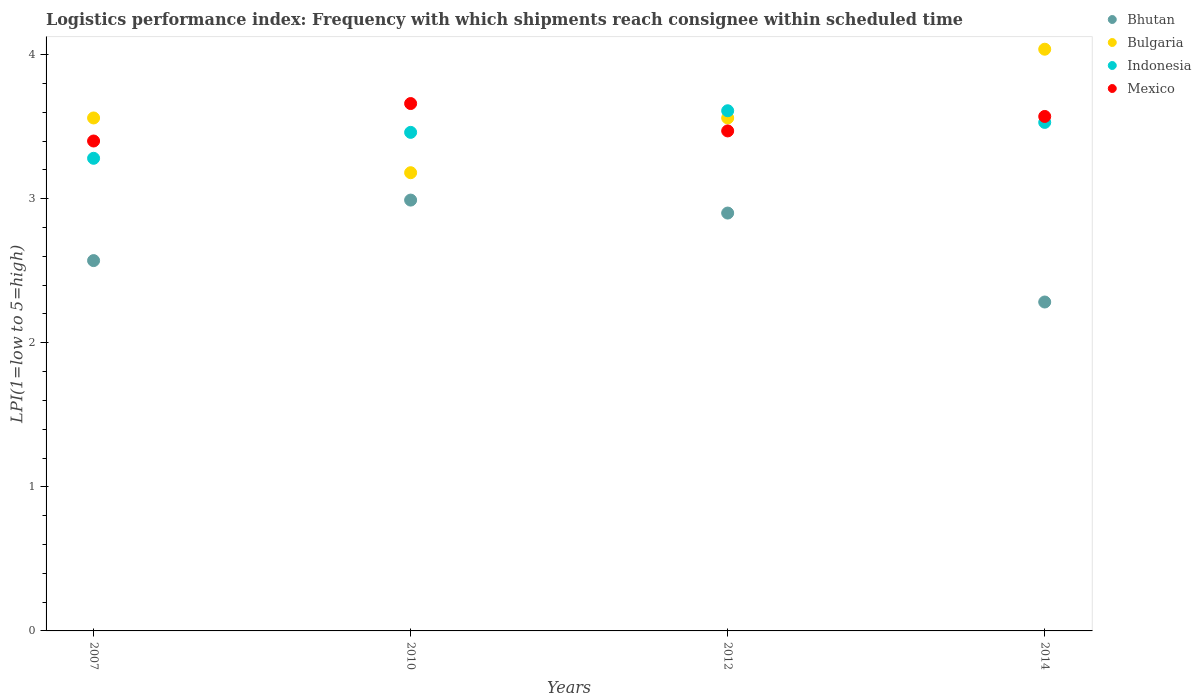Is the number of dotlines equal to the number of legend labels?
Your answer should be compact. Yes. What is the logistics performance index in Mexico in 2010?
Your response must be concise. 3.66. Across all years, what is the maximum logistics performance index in Bulgaria?
Your answer should be compact. 4.04. Across all years, what is the minimum logistics performance index in Bulgaria?
Your answer should be very brief. 3.18. In which year was the logistics performance index in Bulgaria maximum?
Your answer should be compact. 2014. In which year was the logistics performance index in Mexico minimum?
Offer a very short reply. 2007. What is the total logistics performance index in Bulgaria in the graph?
Ensure brevity in your answer.  14.34. What is the difference between the logistics performance index in Indonesia in 2007 and that in 2014?
Your response must be concise. -0.25. What is the difference between the logistics performance index in Indonesia in 2014 and the logistics performance index in Bhutan in 2010?
Offer a very short reply. 0.54. What is the average logistics performance index in Bhutan per year?
Keep it short and to the point. 2.69. In the year 2014, what is the difference between the logistics performance index in Mexico and logistics performance index in Bulgaria?
Ensure brevity in your answer.  -0.47. In how many years, is the logistics performance index in Bulgaria greater than 3.4?
Your answer should be compact. 3. What is the ratio of the logistics performance index in Mexico in 2010 to that in 2014?
Offer a very short reply. 1.03. Is the logistics performance index in Indonesia in 2012 less than that in 2014?
Keep it short and to the point. No. What is the difference between the highest and the second highest logistics performance index in Bulgaria?
Give a very brief answer. 0.48. What is the difference between the highest and the lowest logistics performance index in Mexico?
Your response must be concise. 0.26. In how many years, is the logistics performance index in Mexico greater than the average logistics performance index in Mexico taken over all years?
Your response must be concise. 2. Is it the case that in every year, the sum of the logistics performance index in Indonesia and logistics performance index in Bulgaria  is greater than the logistics performance index in Bhutan?
Make the answer very short. Yes. Does the logistics performance index in Bhutan monotonically increase over the years?
Keep it short and to the point. No. How many dotlines are there?
Your response must be concise. 4. What is the difference between two consecutive major ticks on the Y-axis?
Your answer should be compact. 1. Are the values on the major ticks of Y-axis written in scientific E-notation?
Provide a succinct answer. No. Where does the legend appear in the graph?
Your answer should be very brief. Top right. How many legend labels are there?
Keep it short and to the point. 4. What is the title of the graph?
Offer a terse response. Logistics performance index: Frequency with which shipments reach consignee within scheduled time. What is the label or title of the X-axis?
Provide a short and direct response. Years. What is the label or title of the Y-axis?
Provide a short and direct response. LPI(1=low to 5=high). What is the LPI(1=low to 5=high) in Bhutan in 2007?
Keep it short and to the point. 2.57. What is the LPI(1=low to 5=high) of Bulgaria in 2007?
Provide a succinct answer. 3.56. What is the LPI(1=low to 5=high) in Indonesia in 2007?
Your answer should be very brief. 3.28. What is the LPI(1=low to 5=high) in Mexico in 2007?
Your response must be concise. 3.4. What is the LPI(1=low to 5=high) in Bhutan in 2010?
Offer a terse response. 2.99. What is the LPI(1=low to 5=high) in Bulgaria in 2010?
Provide a succinct answer. 3.18. What is the LPI(1=low to 5=high) in Indonesia in 2010?
Provide a succinct answer. 3.46. What is the LPI(1=low to 5=high) in Mexico in 2010?
Your answer should be very brief. 3.66. What is the LPI(1=low to 5=high) in Bulgaria in 2012?
Provide a succinct answer. 3.56. What is the LPI(1=low to 5=high) in Indonesia in 2012?
Make the answer very short. 3.61. What is the LPI(1=low to 5=high) of Mexico in 2012?
Make the answer very short. 3.47. What is the LPI(1=low to 5=high) in Bhutan in 2014?
Provide a short and direct response. 2.28. What is the LPI(1=low to 5=high) in Bulgaria in 2014?
Offer a very short reply. 4.04. What is the LPI(1=low to 5=high) of Indonesia in 2014?
Provide a succinct answer. 3.53. What is the LPI(1=low to 5=high) in Mexico in 2014?
Make the answer very short. 3.57. Across all years, what is the maximum LPI(1=low to 5=high) of Bhutan?
Make the answer very short. 2.99. Across all years, what is the maximum LPI(1=low to 5=high) of Bulgaria?
Provide a short and direct response. 4.04. Across all years, what is the maximum LPI(1=low to 5=high) of Indonesia?
Ensure brevity in your answer.  3.61. Across all years, what is the maximum LPI(1=low to 5=high) of Mexico?
Make the answer very short. 3.66. Across all years, what is the minimum LPI(1=low to 5=high) of Bhutan?
Make the answer very short. 2.28. Across all years, what is the minimum LPI(1=low to 5=high) of Bulgaria?
Make the answer very short. 3.18. Across all years, what is the minimum LPI(1=low to 5=high) of Indonesia?
Ensure brevity in your answer.  3.28. Across all years, what is the minimum LPI(1=low to 5=high) in Mexico?
Offer a very short reply. 3.4. What is the total LPI(1=low to 5=high) in Bhutan in the graph?
Give a very brief answer. 10.74. What is the total LPI(1=low to 5=high) in Bulgaria in the graph?
Offer a very short reply. 14.34. What is the total LPI(1=low to 5=high) of Indonesia in the graph?
Provide a short and direct response. 13.88. What is the total LPI(1=low to 5=high) of Mexico in the graph?
Your answer should be very brief. 14.1. What is the difference between the LPI(1=low to 5=high) in Bhutan in 2007 and that in 2010?
Provide a succinct answer. -0.42. What is the difference between the LPI(1=low to 5=high) of Bulgaria in 2007 and that in 2010?
Your answer should be very brief. 0.38. What is the difference between the LPI(1=low to 5=high) in Indonesia in 2007 and that in 2010?
Make the answer very short. -0.18. What is the difference between the LPI(1=low to 5=high) in Mexico in 2007 and that in 2010?
Provide a succinct answer. -0.26. What is the difference between the LPI(1=low to 5=high) of Bhutan in 2007 and that in 2012?
Provide a succinct answer. -0.33. What is the difference between the LPI(1=low to 5=high) of Indonesia in 2007 and that in 2012?
Provide a short and direct response. -0.33. What is the difference between the LPI(1=low to 5=high) of Mexico in 2007 and that in 2012?
Provide a succinct answer. -0.07. What is the difference between the LPI(1=low to 5=high) in Bhutan in 2007 and that in 2014?
Your answer should be very brief. 0.29. What is the difference between the LPI(1=low to 5=high) of Bulgaria in 2007 and that in 2014?
Ensure brevity in your answer.  -0.48. What is the difference between the LPI(1=low to 5=high) of Indonesia in 2007 and that in 2014?
Make the answer very short. -0.25. What is the difference between the LPI(1=low to 5=high) of Mexico in 2007 and that in 2014?
Give a very brief answer. -0.17. What is the difference between the LPI(1=low to 5=high) of Bhutan in 2010 and that in 2012?
Provide a short and direct response. 0.09. What is the difference between the LPI(1=low to 5=high) of Bulgaria in 2010 and that in 2012?
Offer a very short reply. -0.38. What is the difference between the LPI(1=low to 5=high) of Indonesia in 2010 and that in 2012?
Your response must be concise. -0.15. What is the difference between the LPI(1=low to 5=high) in Mexico in 2010 and that in 2012?
Your answer should be compact. 0.19. What is the difference between the LPI(1=low to 5=high) of Bhutan in 2010 and that in 2014?
Offer a very short reply. 0.71. What is the difference between the LPI(1=low to 5=high) of Bulgaria in 2010 and that in 2014?
Ensure brevity in your answer.  -0.86. What is the difference between the LPI(1=low to 5=high) of Indonesia in 2010 and that in 2014?
Offer a terse response. -0.07. What is the difference between the LPI(1=low to 5=high) in Mexico in 2010 and that in 2014?
Make the answer very short. 0.09. What is the difference between the LPI(1=low to 5=high) in Bhutan in 2012 and that in 2014?
Provide a succinct answer. 0.62. What is the difference between the LPI(1=low to 5=high) in Bulgaria in 2012 and that in 2014?
Ensure brevity in your answer.  -0.48. What is the difference between the LPI(1=low to 5=high) of Indonesia in 2012 and that in 2014?
Your answer should be very brief. 0.08. What is the difference between the LPI(1=low to 5=high) of Mexico in 2012 and that in 2014?
Give a very brief answer. -0.1. What is the difference between the LPI(1=low to 5=high) of Bhutan in 2007 and the LPI(1=low to 5=high) of Bulgaria in 2010?
Your answer should be very brief. -0.61. What is the difference between the LPI(1=low to 5=high) in Bhutan in 2007 and the LPI(1=low to 5=high) in Indonesia in 2010?
Ensure brevity in your answer.  -0.89. What is the difference between the LPI(1=low to 5=high) in Bhutan in 2007 and the LPI(1=low to 5=high) in Mexico in 2010?
Offer a terse response. -1.09. What is the difference between the LPI(1=low to 5=high) in Bulgaria in 2007 and the LPI(1=low to 5=high) in Indonesia in 2010?
Provide a succinct answer. 0.1. What is the difference between the LPI(1=low to 5=high) of Bulgaria in 2007 and the LPI(1=low to 5=high) of Mexico in 2010?
Keep it short and to the point. -0.1. What is the difference between the LPI(1=low to 5=high) in Indonesia in 2007 and the LPI(1=low to 5=high) in Mexico in 2010?
Your answer should be compact. -0.38. What is the difference between the LPI(1=low to 5=high) in Bhutan in 2007 and the LPI(1=low to 5=high) in Bulgaria in 2012?
Your answer should be compact. -0.99. What is the difference between the LPI(1=low to 5=high) in Bhutan in 2007 and the LPI(1=low to 5=high) in Indonesia in 2012?
Make the answer very short. -1.04. What is the difference between the LPI(1=low to 5=high) of Bulgaria in 2007 and the LPI(1=low to 5=high) of Indonesia in 2012?
Keep it short and to the point. -0.05. What is the difference between the LPI(1=low to 5=high) in Bulgaria in 2007 and the LPI(1=low to 5=high) in Mexico in 2012?
Offer a very short reply. 0.09. What is the difference between the LPI(1=low to 5=high) in Indonesia in 2007 and the LPI(1=low to 5=high) in Mexico in 2012?
Offer a terse response. -0.19. What is the difference between the LPI(1=low to 5=high) in Bhutan in 2007 and the LPI(1=low to 5=high) in Bulgaria in 2014?
Keep it short and to the point. -1.47. What is the difference between the LPI(1=low to 5=high) in Bhutan in 2007 and the LPI(1=low to 5=high) in Indonesia in 2014?
Offer a terse response. -0.96. What is the difference between the LPI(1=low to 5=high) in Bhutan in 2007 and the LPI(1=low to 5=high) in Mexico in 2014?
Your answer should be very brief. -1. What is the difference between the LPI(1=low to 5=high) of Bulgaria in 2007 and the LPI(1=low to 5=high) of Indonesia in 2014?
Your answer should be very brief. 0.03. What is the difference between the LPI(1=low to 5=high) in Bulgaria in 2007 and the LPI(1=low to 5=high) in Mexico in 2014?
Keep it short and to the point. -0.01. What is the difference between the LPI(1=low to 5=high) in Indonesia in 2007 and the LPI(1=low to 5=high) in Mexico in 2014?
Ensure brevity in your answer.  -0.29. What is the difference between the LPI(1=low to 5=high) in Bhutan in 2010 and the LPI(1=low to 5=high) in Bulgaria in 2012?
Provide a short and direct response. -0.57. What is the difference between the LPI(1=low to 5=high) in Bhutan in 2010 and the LPI(1=low to 5=high) in Indonesia in 2012?
Make the answer very short. -0.62. What is the difference between the LPI(1=low to 5=high) in Bhutan in 2010 and the LPI(1=low to 5=high) in Mexico in 2012?
Offer a very short reply. -0.48. What is the difference between the LPI(1=low to 5=high) in Bulgaria in 2010 and the LPI(1=low to 5=high) in Indonesia in 2012?
Provide a short and direct response. -0.43. What is the difference between the LPI(1=low to 5=high) in Bulgaria in 2010 and the LPI(1=low to 5=high) in Mexico in 2012?
Your response must be concise. -0.29. What is the difference between the LPI(1=low to 5=high) in Indonesia in 2010 and the LPI(1=low to 5=high) in Mexico in 2012?
Offer a terse response. -0.01. What is the difference between the LPI(1=low to 5=high) in Bhutan in 2010 and the LPI(1=low to 5=high) in Bulgaria in 2014?
Keep it short and to the point. -1.05. What is the difference between the LPI(1=low to 5=high) of Bhutan in 2010 and the LPI(1=low to 5=high) of Indonesia in 2014?
Give a very brief answer. -0.54. What is the difference between the LPI(1=low to 5=high) of Bhutan in 2010 and the LPI(1=low to 5=high) of Mexico in 2014?
Provide a short and direct response. -0.58. What is the difference between the LPI(1=low to 5=high) in Bulgaria in 2010 and the LPI(1=low to 5=high) in Indonesia in 2014?
Provide a short and direct response. -0.35. What is the difference between the LPI(1=low to 5=high) of Bulgaria in 2010 and the LPI(1=low to 5=high) of Mexico in 2014?
Keep it short and to the point. -0.39. What is the difference between the LPI(1=low to 5=high) of Indonesia in 2010 and the LPI(1=low to 5=high) of Mexico in 2014?
Offer a very short reply. -0.11. What is the difference between the LPI(1=low to 5=high) in Bhutan in 2012 and the LPI(1=low to 5=high) in Bulgaria in 2014?
Make the answer very short. -1.14. What is the difference between the LPI(1=low to 5=high) in Bhutan in 2012 and the LPI(1=low to 5=high) in Indonesia in 2014?
Offer a very short reply. -0.63. What is the difference between the LPI(1=low to 5=high) in Bhutan in 2012 and the LPI(1=low to 5=high) in Mexico in 2014?
Provide a succinct answer. -0.67. What is the difference between the LPI(1=low to 5=high) of Bulgaria in 2012 and the LPI(1=low to 5=high) of Indonesia in 2014?
Provide a short and direct response. 0.03. What is the difference between the LPI(1=low to 5=high) in Bulgaria in 2012 and the LPI(1=low to 5=high) in Mexico in 2014?
Your answer should be very brief. -0.01. What is the difference between the LPI(1=low to 5=high) of Indonesia in 2012 and the LPI(1=low to 5=high) of Mexico in 2014?
Give a very brief answer. 0.04. What is the average LPI(1=low to 5=high) of Bhutan per year?
Keep it short and to the point. 2.69. What is the average LPI(1=low to 5=high) of Bulgaria per year?
Keep it short and to the point. 3.58. What is the average LPI(1=low to 5=high) of Indonesia per year?
Your answer should be very brief. 3.47. What is the average LPI(1=low to 5=high) in Mexico per year?
Your answer should be very brief. 3.53. In the year 2007, what is the difference between the LPI(1=low to 5=high) of Bhutan and LPI(1=low to 5=high) of Bulgaria?
Provide a short and direct response. -0.99. In the year 2007, what is the difference between the LPI(1=low to 5=high) of Bhutan and LPI(1=low to 5=high) of Indonesia?
Keep it short and to the point. -0.71. In the year 2007, what is the difference between the LPI(1=low to 5=high) in Bhutan and LPI(1=low to 5=high) in Mexico?
Provide a short and direct response. -0.83. In the year 2007, what is the difference between the LPI(1=low to 5=high) of Bulgaria and LPI(1=low to 5=high) of Indonesia?
Your response must be concise. 0.28. In the year 2007, what is the difference between the LPI(1=low to 5=high) in Bulgaria and LPI(1=low to 5=high) in Mexico?
Your response must be concise. 0.16. In the year 2007, what is the difference between the LPI(1=low to 5=high) of Indonesia and LPI(1=low to 5=high) of Mexico?
Your answer should be very brief. -0.12. In the year 2010, what is the difference between the LPI(1=low to 5=high) in Bhutan and LPI(1=low to 5=high) in Bulgaria?
Give a very brief answer. -0.19. In the year 2010, what is the difference between the LPI(1=low to 5=high) in Bhutan and LPI(1=low to 5=high) in Indonesia?
Your response must be concise. -0.47. In the year 2010, what is the difference between the LPI(1=low to 5=high) of Bhutan and LPI(1=low to 5=high) of Mexico?
Your answer should be very brief. -0.67. In the year 2010, what is the difference between the LPI(1=low to 5=high) in Bulgaria and LPI(1=low to 5=high) in Indonesia?
Offer a terse response. -0.28. In the year 2010, what is the difference between the LPI(1=low to 5=high) of Bulgaria and LPI(1=low to 5=high) of Mexico?
Provide a short and direct response. -0.48. In the year 2010, what is the difference between the LPI(1=low to 5=high) in Indonesia and LPI(1=low to 5=high) in Mexico?
Provide a short and direct response. -0.2. In the year 2012, what is the difference between the LPI(1=low to 5=high) of Bhutan and LPI(1=low to 5=high) of Bulgaria?
Provide a short and direct response. -0.66. In the year 2012, what is the difference between the LPI(1=low to 5=high) in Bhutan and LPI(1=low to 5=high) in Indonesia?
Provide a short and direct response. -0.71. In the year 2012, what is the difference between the LPI(1=low to 5=high) in Bhutan and LPI(1=low to 5=high) in Mexico?
Your response must be concise. -0.57. In the year 2012, what is the difference between the LPI(1=low to 5=high) of Bulgaria and LPI(1=low to 5=high) of Mexico?
Offer a terse response. 0.09. In the year 2012, what is the difference between the LPI(1=low to 5=high) of Indonesia and LPI(1=low to 5=high) of Mexico?
Make the answer very short. 0.14. In the year 2014, what is the difference between the LPI(1=low to 5=high) of Bhutan and LPI(1=low to 5=high) of Bulgaria?
Your answer should be very brief. -1.75. In the year 2014, what is the difference between the LPI(1=low to 5=high) of Bhutan and LPI(1=low to 5=high) of Indonesia?
Keep it short and to the point. -1.25. In the year 2014, what is the difference between the LPI(1=low to 5=high) of Bhutan and LPI(1=low to 5=high) of Mexico?
Your response must be concise. -1.29. In the year 2014, what is the difference between the LPI(1=low to 5=high) in Bulgaria and LPI(1=low to 5=high) in Indonesia?
Your answer should be very brief. 0.51. In the year 2014, what is the difference between the LPI(1=low to 5=high) in Bulgaria and LPI(1=low to 5=high) in Mexico?
Provide a succinct answer. 0.47. In the year 2014, what is the difference between the LPI(1=low to 5=high) of Indonesia and LPI(1=low to 5=high) of Mexico?
Your answer should be compact. -0.04. What is the ratio of the LPI(1=low to 5=high) of Bhutan in 2007 to that in 2010?
Offer a terse response. 0.86. What is the ratio of the LPI(1=low to 5=high) of Bulgaria in 2007 to that in 2010?
Offer a terse response. 1.12. What is the ratio of the LPI(1=low to 5=high) in Indonesia in 2007 to that in 2010?
Offer a very short reply. 0.95. What is the ratio of the LPI(1=low to 5=high) of Mexico in 2007 to that in 2010?
Offer a very short reply. 0.93. What is the ratio of the LPI(1=low to 5=high) in Bhutan in 2007 to that in 2012?
Ensure brevity in your answer.  0.89. What is the ratio of the LPI(1=low to 5=high) of Indonesia in 2007 to that in 2012?
Ensure brevity in your answer.  0.91. What is the ratio of the LPI(1=low to 5=high) of Mexico in 2007 to that in 2012?
Give a very brief answer. 0.98. What is the ratio of the LPI(1=low to 5=high) in Bhutan in 2007 to that in 2014?
Keep it short and to the point. 1.13. What is the ratio of the LPI(1=low to 5=high) of Bulgaria in 2007 to that in 2014?
Offer a terse response. 0.88. What is the ratio of the LPI(1=low to 5=high) of Indonesia in 2007 to that in 2014?
Your answer should be very brief. 0.93. What is the ratio of the LPI(1=low to 5=high) in Mexico in 2007 to that in 2014?
Your answer should be very brief. 0.95. What is the ratio of the LPI(1=low to 5=high) of Bhutan in 2010 to that in 2012?
Your answer should be very brief. 1.03. What is the ratio of the LPI(1=low to 5=high) in Bulgaria in 2010 to that in 2012?
Your answer should be compact. 0.89. What is the ratio of the LPI(1=low to 5=high) of Indonesia in 2010 to that in 2012?
Provide a succinct answer. 0.96. What is the ratio of the LPI(1=low to 5=high) of Mexico in 2010 to that in 2012?
Offer a terse response. 1.05. What is the ratio of the LPI(1=low to 5=high) in Bhutan in 2010 to that in 2014?
Provide a succinct answer. 1.31. What is the ratio of the LPI(1=low to 5=high) in Bulgaria in 2010 to that in 2014?
Your answer should be very brief. 0.79. What is the ratio of the LPI(1=low to 5=high) in Indonesia in 2010 to that in 2014?
Provide a short and direct response. 0.98. What is the ratio of the LPI(1=low to 5=high) of Mexico in 2010 to that in 2014?
Provide a short and direct response. 1.03. What is the ratio of the LPI(1=low to 5=high) of Bhutan in 2012 to that in 2014?
Provide a short and direct response. 1.27. What is the ratio of the LPI(1=low to 5=high) in Bulgaria in 2012 to that in 2014?
Your answer should be very brief. 0.88. What is the ratio of the LPI(1=low to 5=high) in Indonesia in 2012 to that in 2014?
Make the answer very short. 1.02. What is the ratio of the LPI(1=low to 5=high) of Mexico in 2012 to that in 2014?
Your answer should be compact. 0.97. What is the difference between the highest and the second highest LPI(1=low to 5=high) of Bhutan?
Offer a very short reply. 0.09. What is the difference between the highest and the second highest LPI(1=low to 5=high) of Bulgaria?
Your answer should be compact. 0.48. What is the difference between the highest and the second highest LPI(1=low to 5=high) of Indonesia?
Your answer should be very brief. 0.08. What is the difference between the highest and the second highest LPI(1=low to 5=high) in Mexico?
Provide a short and direct response. 0.09. What is the difference between the highest and the lowest LPI(1=low to 5=high) of Bhutan?
Make the answer very short. 0.71. What is the difference between the highest and the lowest LPI(1=low to 5=high) in Indonesia?
Ensure brevity in your answer.  0.33. What is the difference between the highest and the lowest LPI(1=low to 5=high) of Mexico?
Offer a terse response. 0.26. 